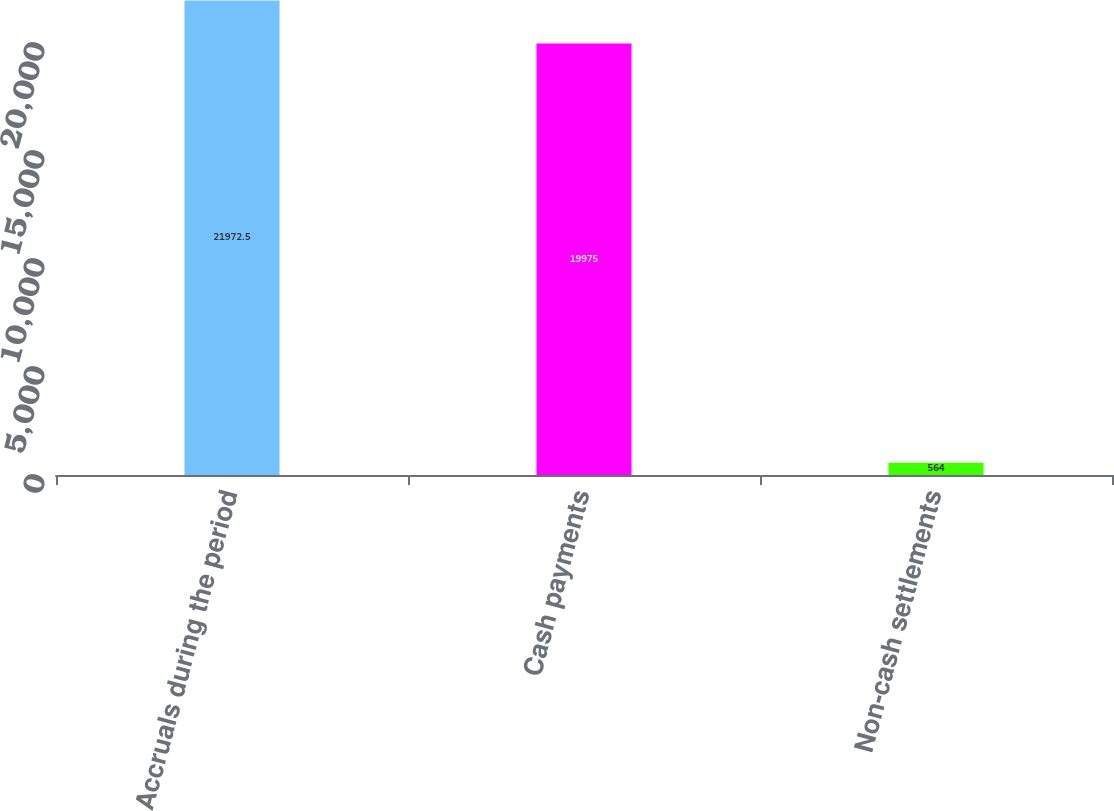Convert chart. <chart><loc_0><loc_0><loc_500><loc_500><bar_chart><fcel>Accruals during the period<fcel>Cash payments<fcel>Non-cash settlements<nl><fcel>21972.5<fcel>19975<fcel>564<nl></chart> 